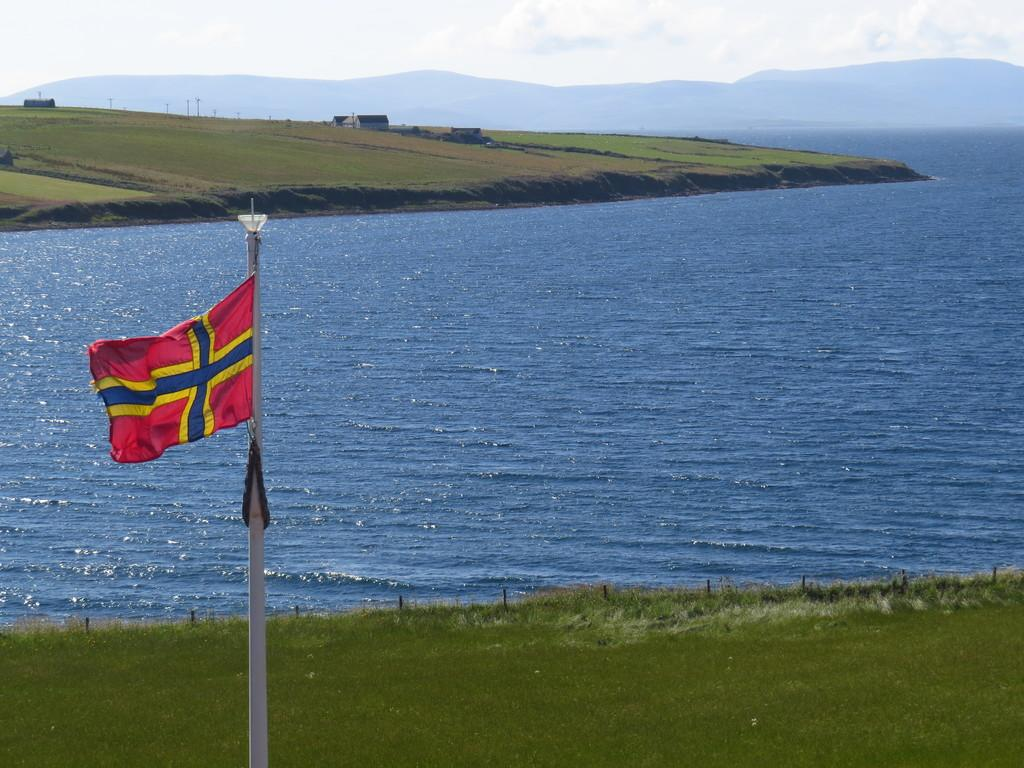What is located on the left side of the image? There is a flag on the left side of the image. What type of terrain is visible at the bottom of the image? Grass is present at the bottom of the image. What can be seen in the center of the image? There is a river in the center of the image. What structures are visible in the background of the image? There are sheds in the background of the image. What type of natural features are visible in the background of the image? There are hills in the background of the image. What is visible in the sky in the background of the image? The sky is visible in the background of the image. How many bikes are parked near the sheds in the image? There are no bikes present in the image. What type of hook is attached to the flagpole in the image? There is no hook present on the flagpole in the image. 